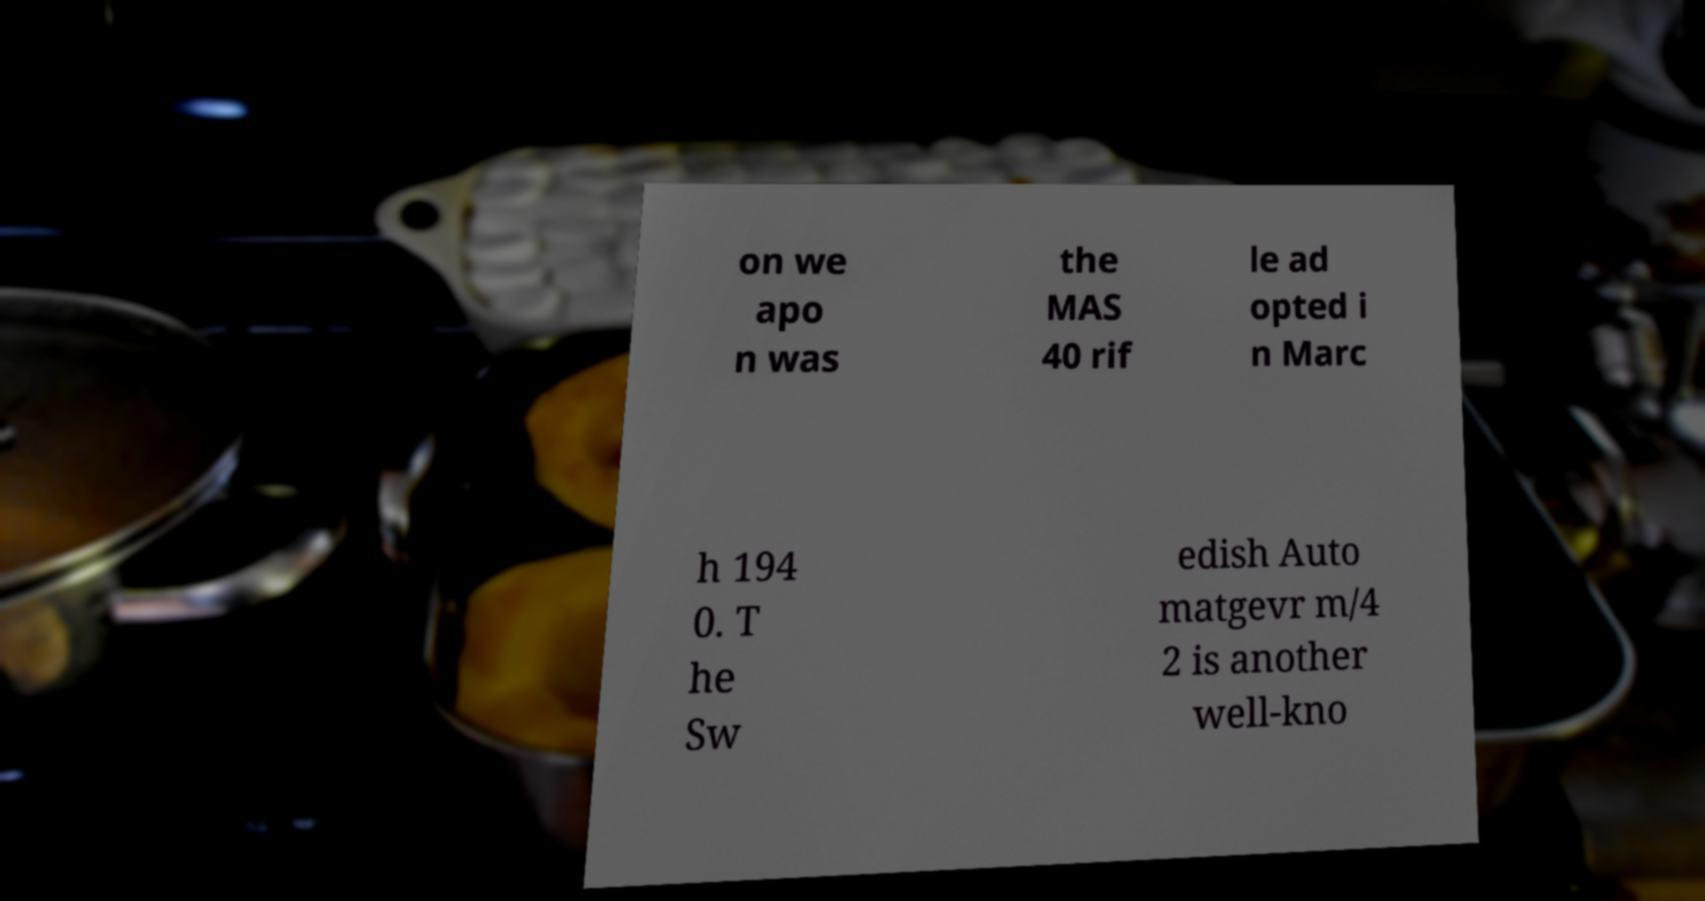Can you read and provide the text displayed in the image?This photo seems to have some interesting text. Can you extract and type it out for me? on we apo n was the MAS 40 rif le ad opted i n Marc h 194 0. T he Sw edish Auto matgevr m/4 2 is another well-kno 